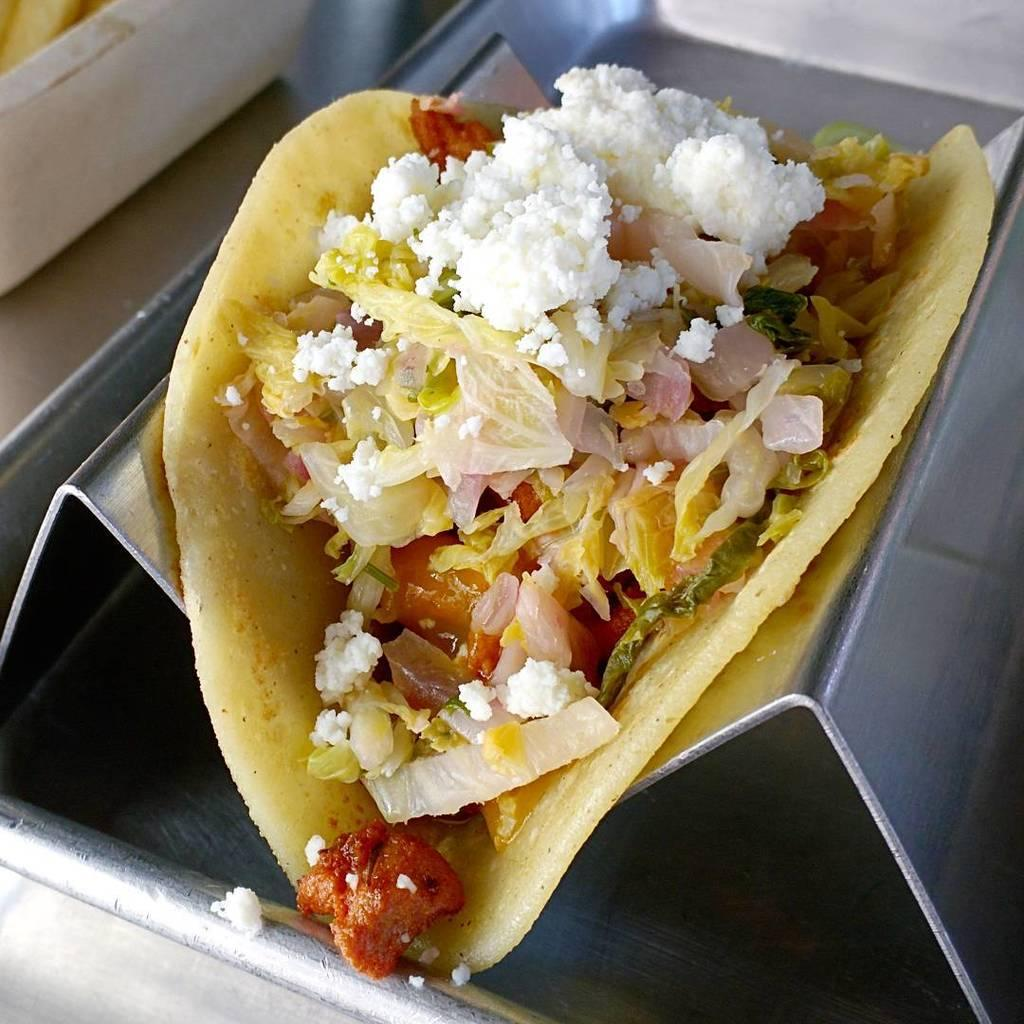What is the main subject of the image? The main subject of the image is food. Can you describe the object below the food? Unfortunately, the facts provided do not give enough information to describe the object below the food. What is located at the left top most of the image? There is an object at the left top most of the image, but the facts do not specify what it is. How does the pet interact with the expert in the image? There is no pet or expert present in the image, so this interaction cannot be observed. 